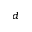<formula> <loc_0><loc_0><loc_500><loc_500>_ { d }</formula> 